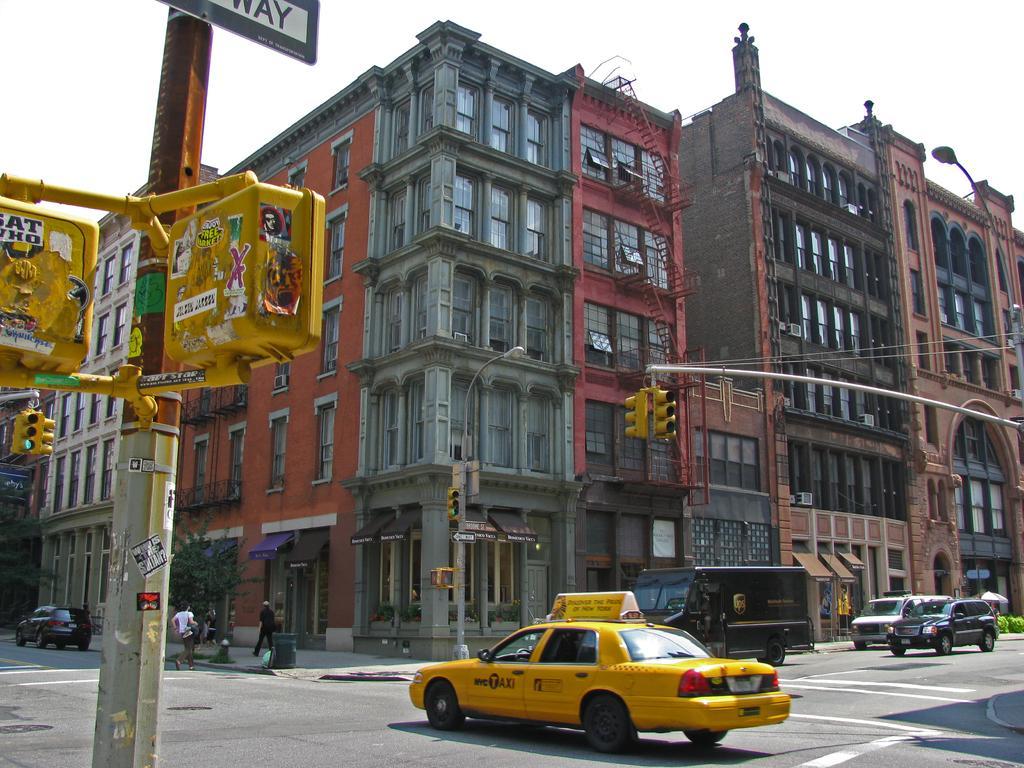In one or two sentences, can you explain what this image depicts? In this image there are few cars and vehicles are on the road. Person is walking on the pavement having poles and trees on it. A traffic light is attached to a pole which is having a lamp to it. Right side there is a pole having few traffic lights attached to it. Left side there is a pole having few lights attached to it. Background there are few buildings. Top of image there is sky. 